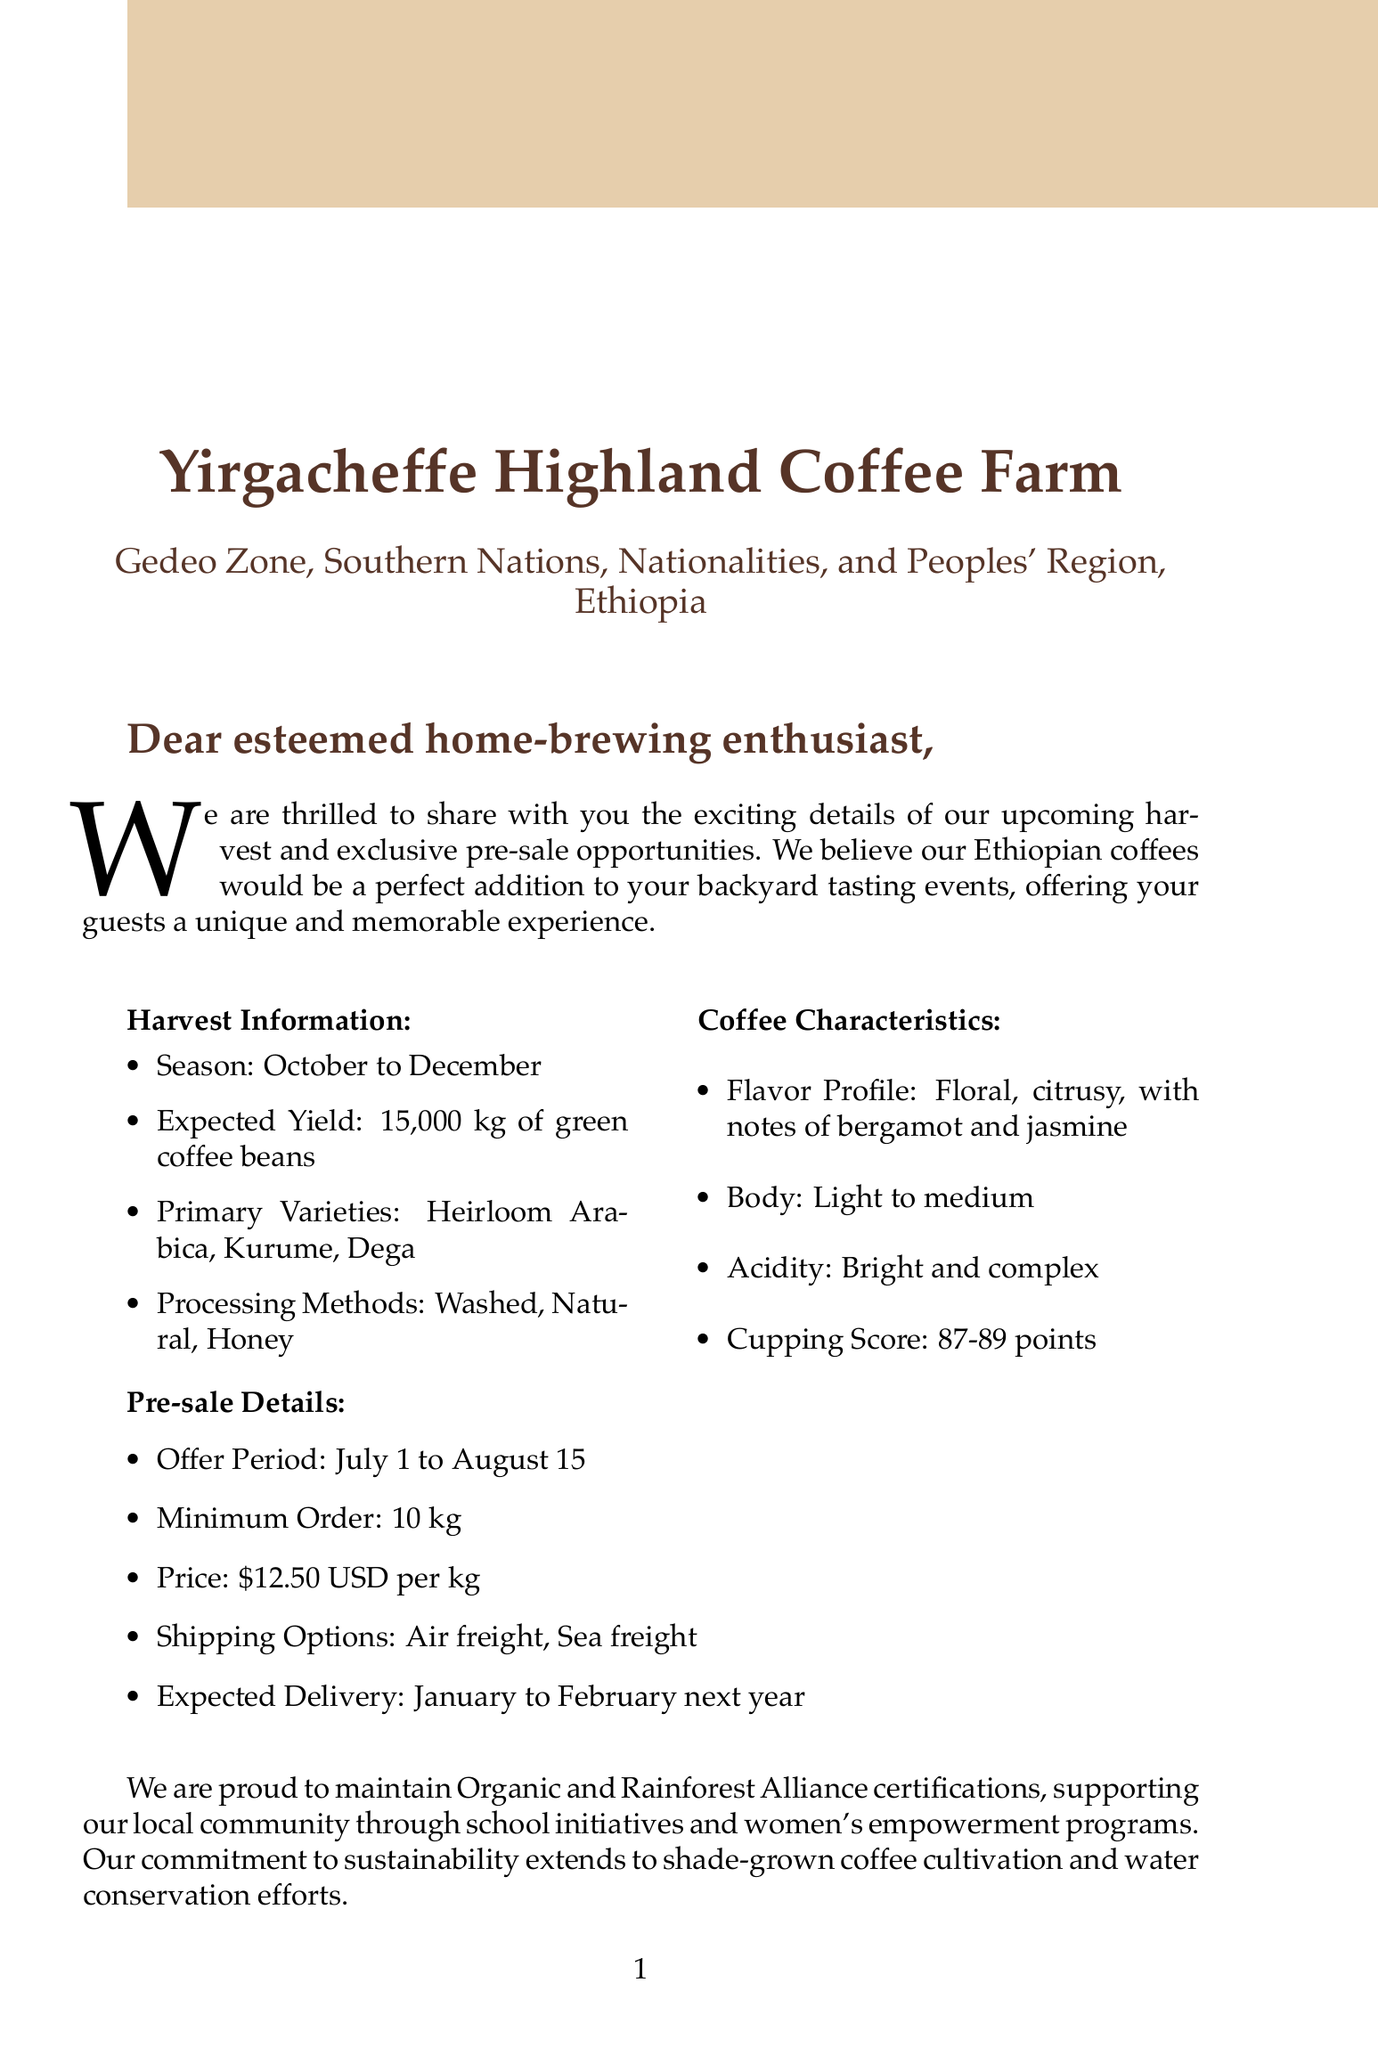What is the name of the coffee farm? The document specifies the name of the coffee farm as Yirgacheffe Highland Coffee Farm.
Answer: Yirgacheffe Highland Coffee Farm Who is the owner of the farm? The letter identifies Abebe Bekele as the owner of the coffee farm.
Answer: Abebe Bekele What is the expected yield for the upcoming harvest? According to the document, the expected yield is 15,000 kg of green coffee beans.
Answer: 15,000 kg What are the primary varieties of coffee mentioned? The document lists Heirloom Arabica, Kurume, and Dega as the primary varieties.
Answer: Heirloom Arabica, Kurume, Dega What is the price per kilogram during the pre-sale? The letter indicates the price per kilogram during the pre-sale is $12.50 USD.
Answer: $12.50 USD What certifications does the farm hold? The document mentions that the farm has Organic and Rainforest Alliance certifications.
Answer: Organic, Rainforest Alliance During which dates can visitors come to the farm? The visiting dates noted in the document are from November 15 to December 5.
Answer: November 15 to December 5 What activities can visitors expect during their visit? The document outlines that activities include coffee picking, processing demonstration, and cupping sessions.
Answer: Coffee picking, processing demonstration, cupping sessions What shipping options are available for orders? The document states that air freight and sea freight are available as shipping options.
Answer: Air freight, Sea freight 